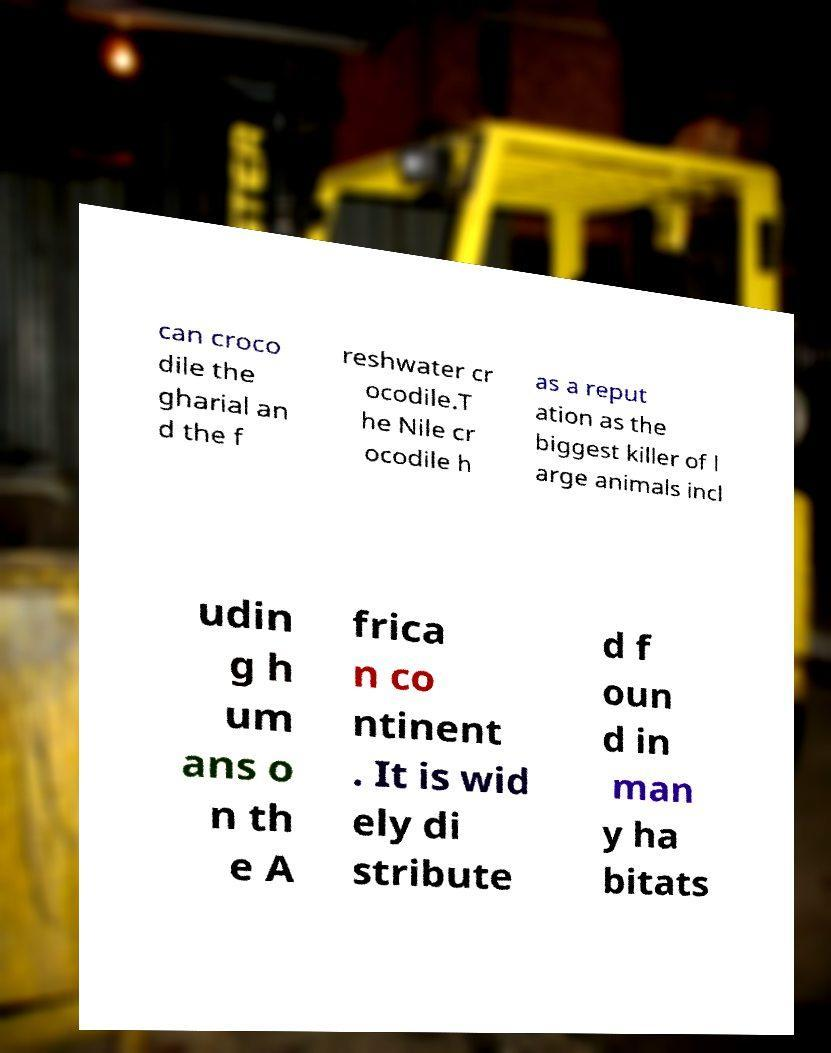There's text embedded in this image that I need extracted. Can you transcribe it verbatim? can croco dile the gharial an d the f reshwater cr ocodile.T he Nile cr ocodile h as a reput ation as the biggest killer of l arge animals incl udin g h um ans o n th e A frica n co ntinent . It is wid ely di stribute d f oun d in man y ha bitats 